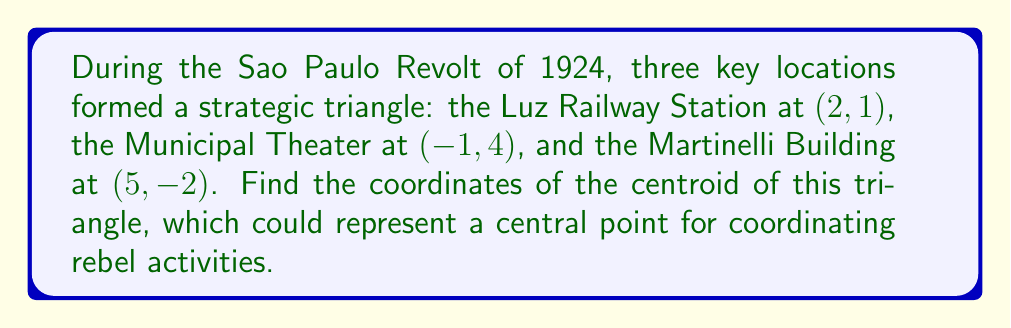Teach me how to tackle this problem. To find the centroid of a triangle, we need to follow these steps:

1) The centroid of a triangle is located at the intersection of its medians. A median is a line segment that connects a vertex to the midpoint of the opposite side.

2) The coordinates of the centroid can be calculated using the following formulas:

   $$x_{\text{centroid}} = \frac{x_1 + x_2 + x_3}{3}$$
   $$y_{\text{centroid}} = \frac{y_1 + y_2 + y_3}{3}$$

   Where $(x_1, y_1)$, $(x_2, y_2)$, and $(x_3, y_3)$ are the coordinates of the three vertices of the triangle.

3) In this case, we have:
   
   Luz Railway Station: $(x_1, y_1) = (2, 1)$
   Municipal Theater: $(x_2, y_2) = (-1, 4)$
   Martinelli Building: $(x_3, y_3) = (5, -2)$

4) Let's substitute these into our formulas:

   $$x_{\text{centroid}} = \frac{2 + (-1) + 5}{3} = \frac{6}{3} = 2$$
   
   $$y_{\text{centroid}} = \frac{1 + 4 + (-2)}{3} = \frac{3}{3} = 1$$

5) Therefore, the coordinates of the centroid are (2, 1).

[asy]
unitsize(1cm);
pair A = (2,1);
pair B = (-1,4);
pair C = (5,-2);
pair G = (2,1);

draw(A--B--C--cycle);
draw(A--G,dashed);
draw(B--G,dashed);
draw(C--G,dashed);

dot("A (2,1)",A,NE);
dot("B (-1,4)",B,NW);
dot("C (5,-2)",C,SE);
dot("G (2,1)",G,S);

xaxis(-2,6,arrow=Arrow);
yaxis(-3,5,arrow=Arrow);
[/asy]

This point (2, 1) represents the geometric center of the triangle formed by these three significant locations during the Sao Paulo Revolt of 1924.
Answer: The coordinates of the centroid are (2, 1). 